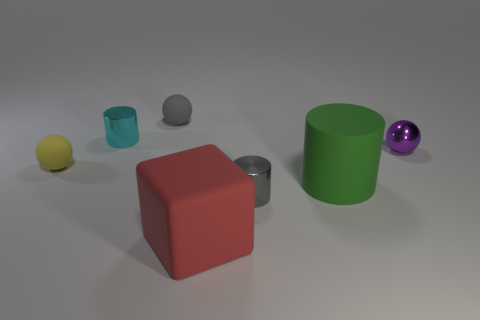Add 3 small metal cylinders. How many objects exist? 10 Subtract all gray cylinders. How many cylinders are left? 2 Subtract all cubes. How many objects are left? 6 Subtract all small yellow balls. Subtract all green rubber objects. How many objects are left? 5 Add 4 gray metallic things. How many gray metallic things are left? 5 Add 1 small brown metal spheres. How many small brown metal spheres exist? 1 Subtract 0 cyan cubes. How many objects are left? 7 